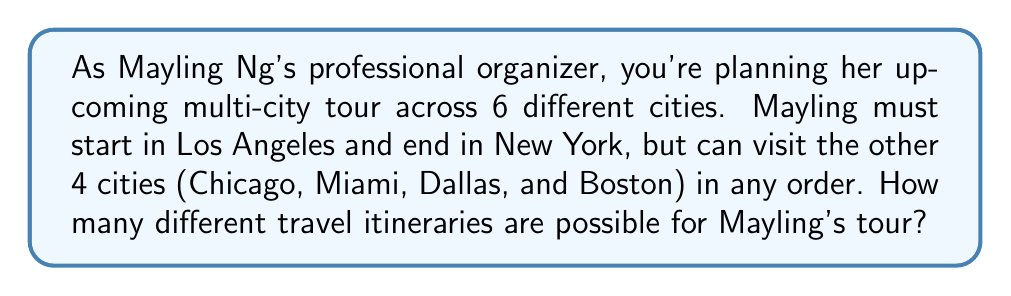Help me with this question. Let's approach this step-by-step:

1) We know that Mayling must start in Los Angeles and end in New York. This means we don't need to consider these cities in our permutation calculation.

2) We are left with 4 cities (Chicago, Miami, Dallas, and Boston) that can be arranged in any order.

3) This is a straightforward permutation problem. We need to calculate how many ways we can arrange 4 distinct items.

4) The formula for permutations of n distinct objects is:

   $$P(n) = n!$$

   Where $n!$ represents the factorial of n.

5) In this case, $n = 4$, so we need to calculate $4!$:

   $$4! = 4 \times 3 \times 2 \times 1 = 24$$

6) Therefore, there are 24 different ways to arrange these 4 cities.

7) Each of these arrangements represents a unique itinerary for Mayling's tour, starting in Los Angeles and ending in New York.

Thus, there are 24 possible travel itineraries for Mayling's multi-city tour.
Answer: 24 